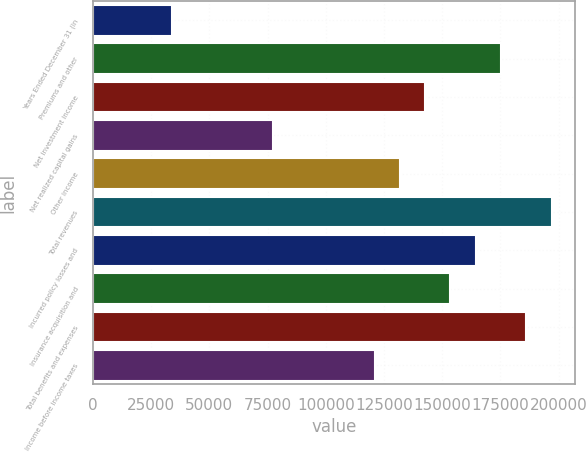Convert chart. <chart><loc_0><loc_0><loc_500><loc_500><bar_chart><fcel>Years Ended December 31 (in<fcel>Premiums and other<fcel>Net investment income<fcel>Net realized capital gains<fcel>Other income<fcel>Total revenues<fcel>Incurred policy losses and<fcel>Insurance acquisition and<fcel>Total benefits and expenses<fcel>Income before income taxes<nl><fcel>33920.8<fcel>175330<fcel>142697<fcel>77431.2<fcel>131819<fcel>197085<fcel>164452<fcel>153574<fcel>186207<fcel>120942<nl></chart> 